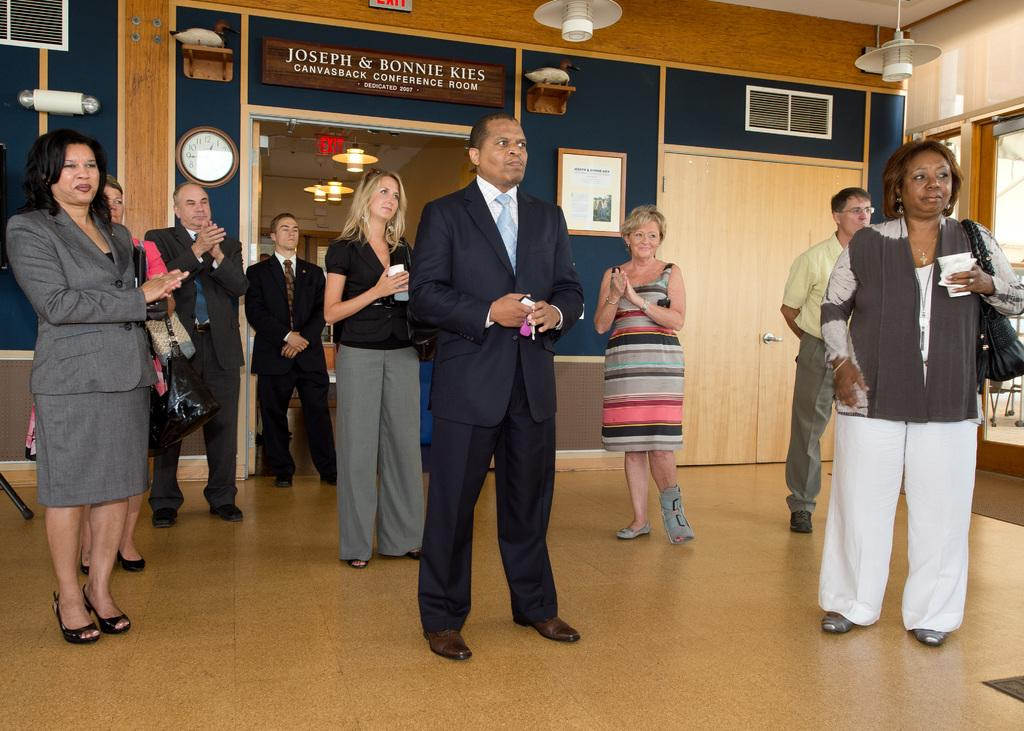How many people are in the image? There is a group of people in the image. What is the position of the people in the image? The people are standing on the floor. What can be seen in the background of the image? In the background of the image, there are name boards, lights, doors, walls, a frame, a clock, statues, and some objects. What type of car is parked in front of the group of people in the image? There is no car present in the image; it only features a group of people standing on the floor and various elements in the background. What type of crime is being committed by the group of people in the image? There is no indication of any crime being committed by the group of people in the image. 